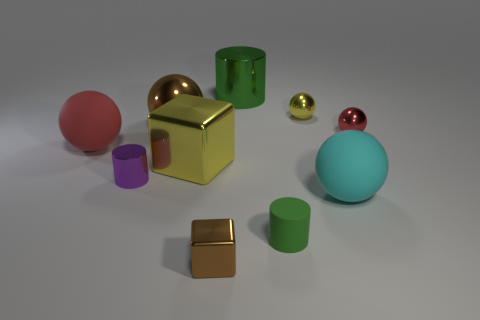Subtract all purple cylinders. How many red spheres are left? 2 Subtract all yellow shiny balls. How many balls are left? 4 Subtract all brown spheres. How many spheres are left? 4 Subtract all cylinders. How many objects are left? 7 Subtract all brown spheres. Subtract all red cubes. How many spheres are left? 4 Subtract 2 red balls. How many objects are left? 8 Subtract all large metallic things. Subtract all tiny purple cylinders. How many objects are left? 6 Add 4 big shiny things. How many big shiny things are left? 7 Add 4 green cylinders. How many green cylinders exist? 6 